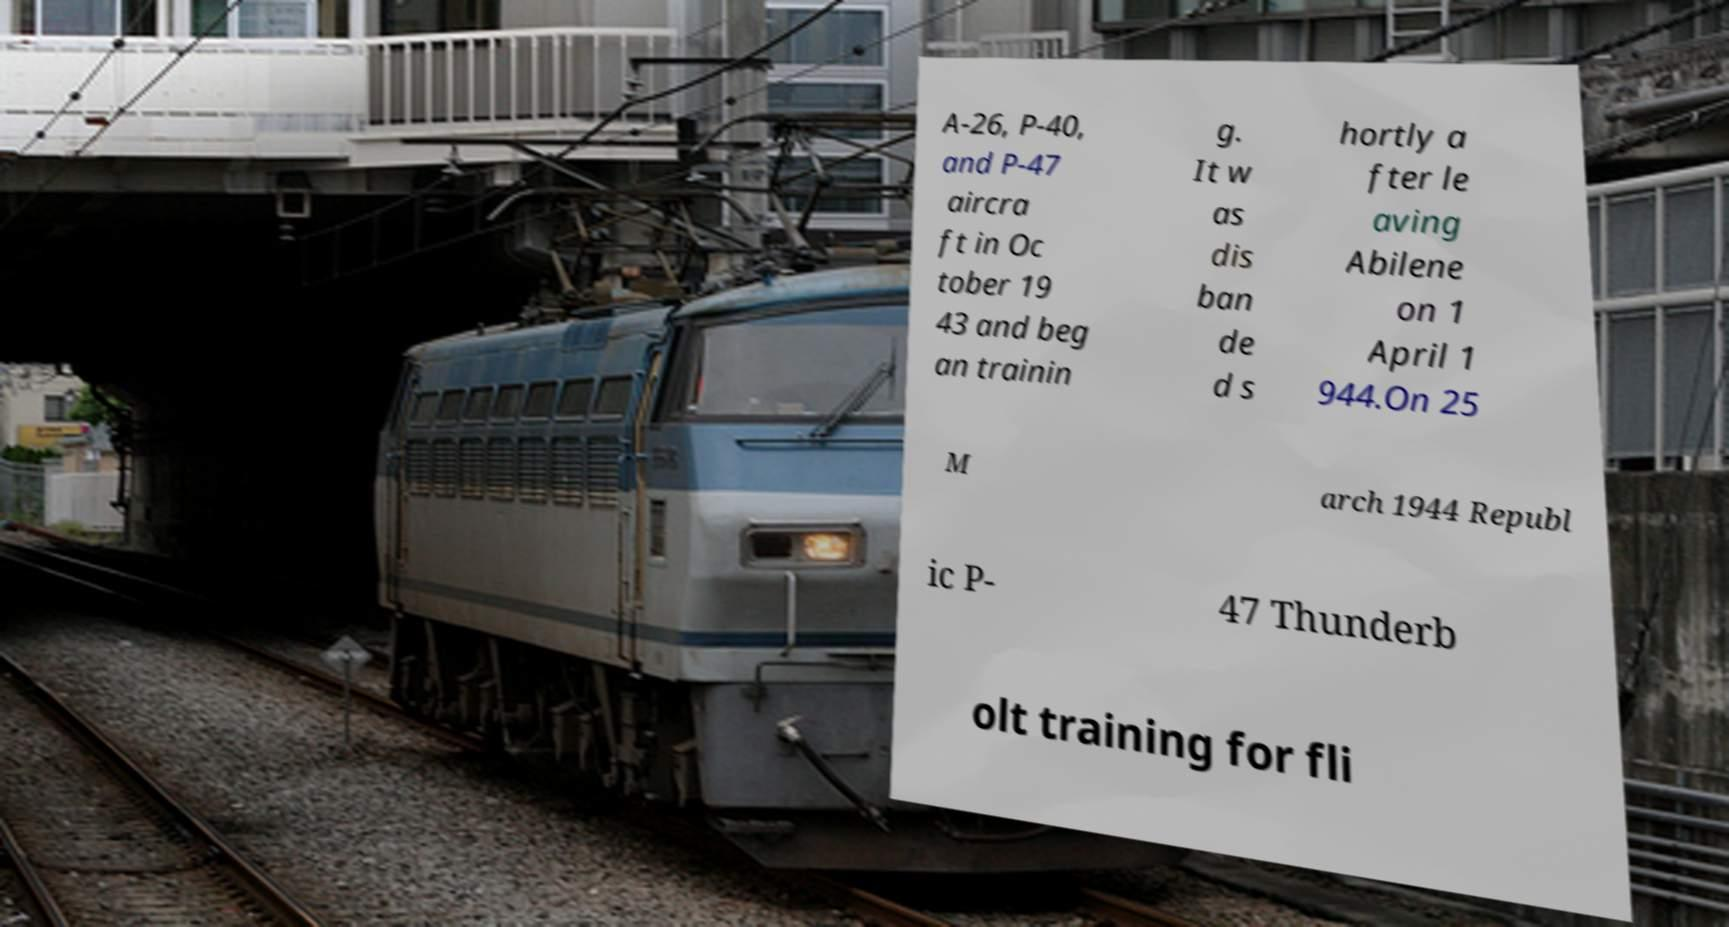Could you extract and type out the text from this image? A-26, P-40, and P-47 aircra ft in Oc tober 19 43 and beg an trainin g. It w as dis ban de d s hortly a fter le aving Abilene on 1 April 1 944.On 25 M arch 1944 Republ ic P- 47 Thunderb olt training for fli 